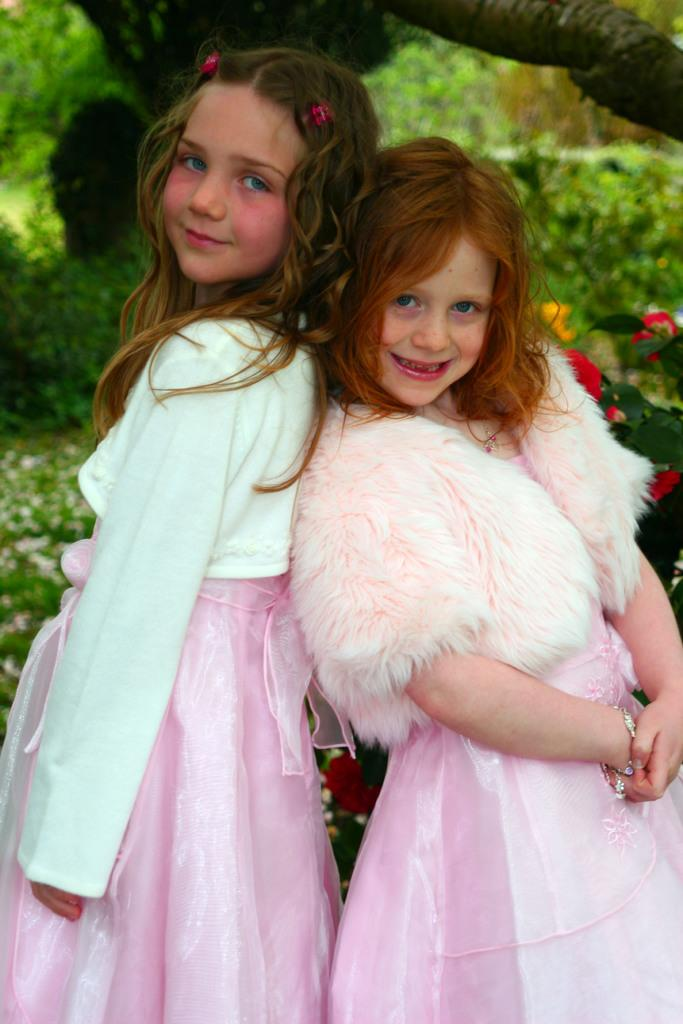How many people are in the image? There are two girls in the image. What is the facial expression of the girls? The girls are smiling. What can be seen in the background of the image? There are flowers and trees in the background of the image. What type of mint is growing on the trees in the image? There is no mint growing on the trees in the image; the trees are not described as having any specific type of plant or vegetation. 